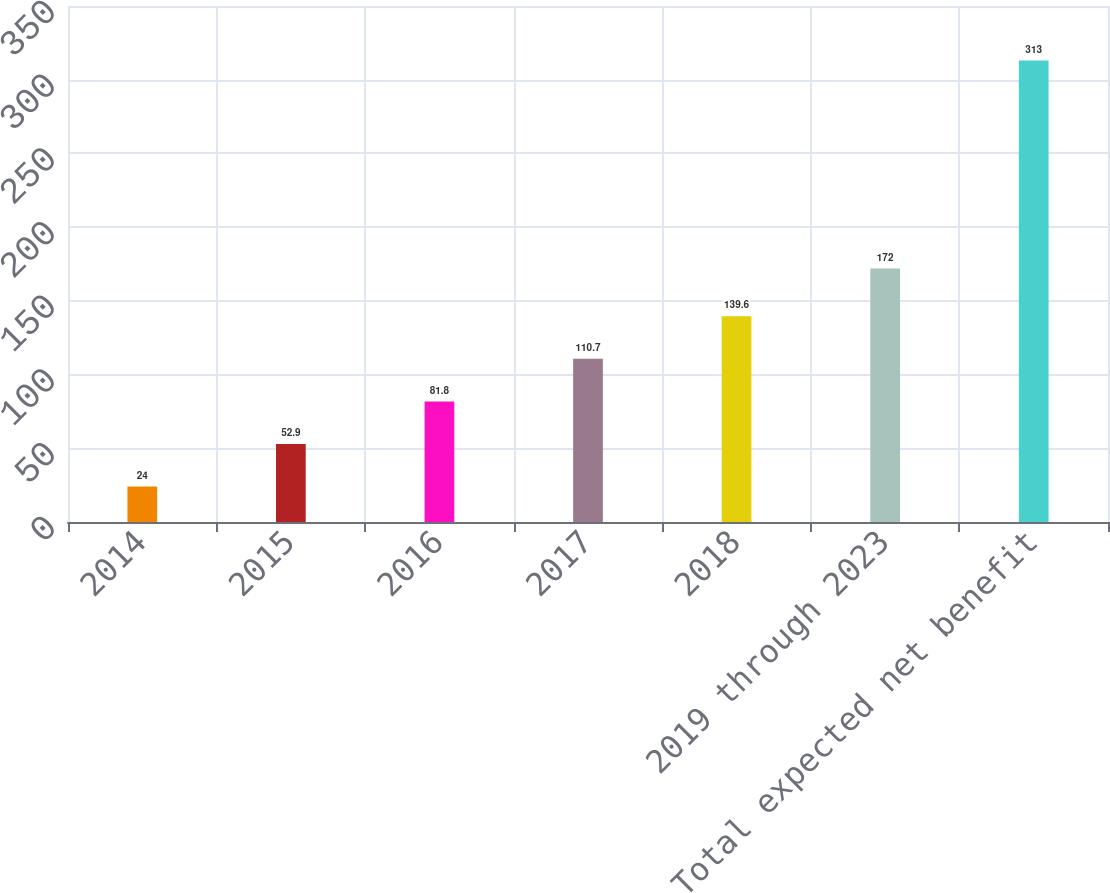Convert chart. <chart><loc_0><loc_0><loc_500><loc_500><bar_chart><fcel>2014<fcel>2015<fcel>2016<fcel>2017<fcel>2018<fcel>2019 through 2023<fcel>Total expected net benefit<nl><fcel>24<fcel>52.9<fcel>81.8<fcel>110.7<fcel>139.6<fcel>172<fcel>313<nl></chart> 